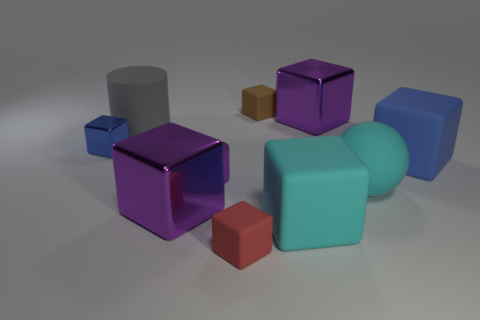Is the color of the large rubber cylinder the same as the thing on the right side of the cyan sphere?
Provide a succinct answer. No. What is the shape of the matte thing that is the same color as the matte sphere?
Your answer should be compact. Cube. What is the shape of the small red thing?
Provide a short and direct response. Cube. Is the small metal cube the same color as the big matte cylinder?
Your response must be concise. No. How many objects are either large purple metallic blocks that are to the right of the cyan cube or small purple shiny things?
Your response must be concise. 2. What size is the sphere that is made of the same material as the tiny brown object?
Make the answer very short. Large. Are there more big gray matte cylinders left of the blue metal object than big matte objects?
Ensure brevity in your answer.  No. There is a small red thing; is its shape the same as the large metal object that is in front of the tiny purple cylinder?
Offer a very short reply. Yes. What number of big things are yellow shiny balls or brown things?
Your answer should be very brief. 0. There is a rubber thing that is the same color as the large sphere; what size is it?
Keep it short and to the point. Large. 